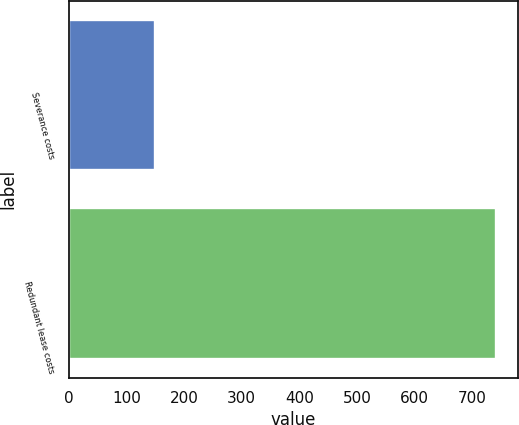<chart> <loc_0><loc_0><loc_500><loc_500><bar_chart><fcel>Severance costs<fcel>Redundant lease costs<nl><fcel>149<fcel>742<nl></chart> 